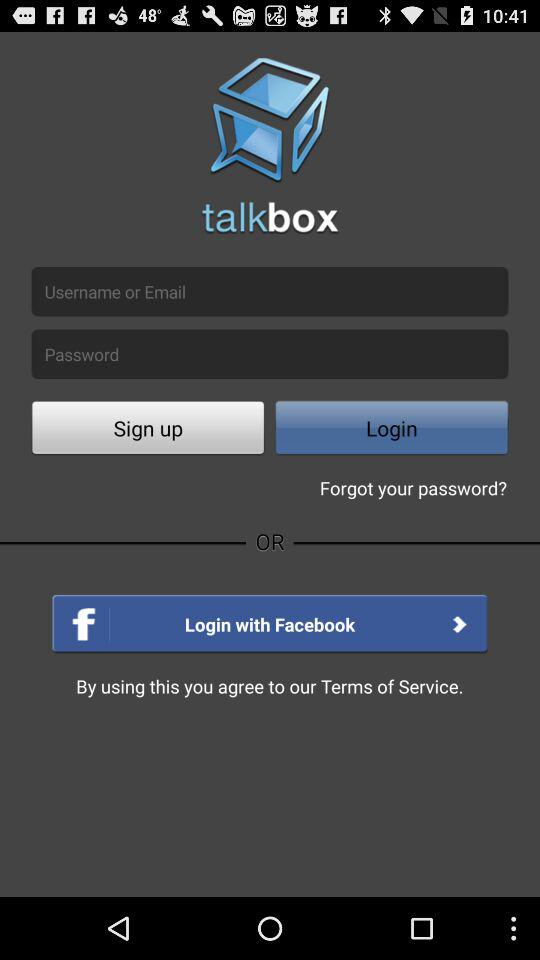What security features can you infer from the login page of the application? From the login page, it’s evident that the application employs standard security practices. The presence of a password entry field implies the use of password protection for user accounts, which is fundamental for user privacy and security. The option to log in with Facebook can also suggest an integration of OAuth authentication, which allows for secure and streamlined user verification without storing password data directly. 